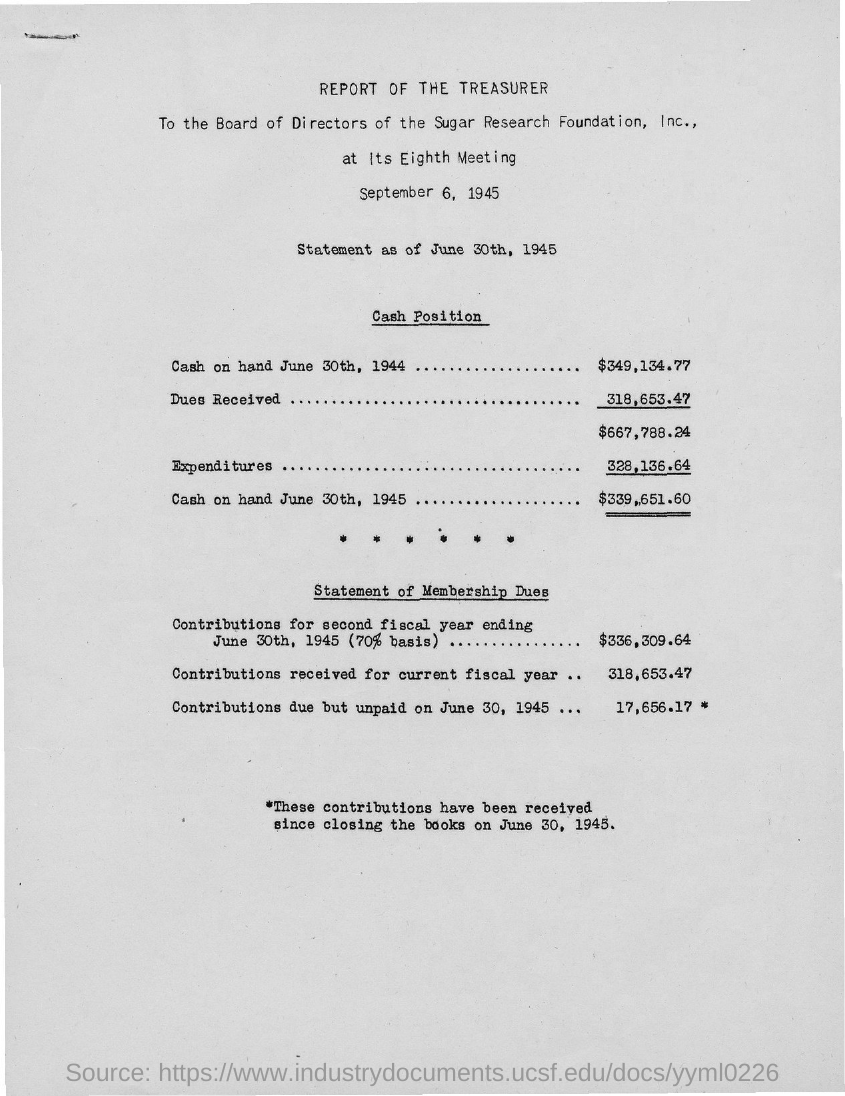Specify some key components in this picture. The document is titled 'Report of the Treasurer.'  